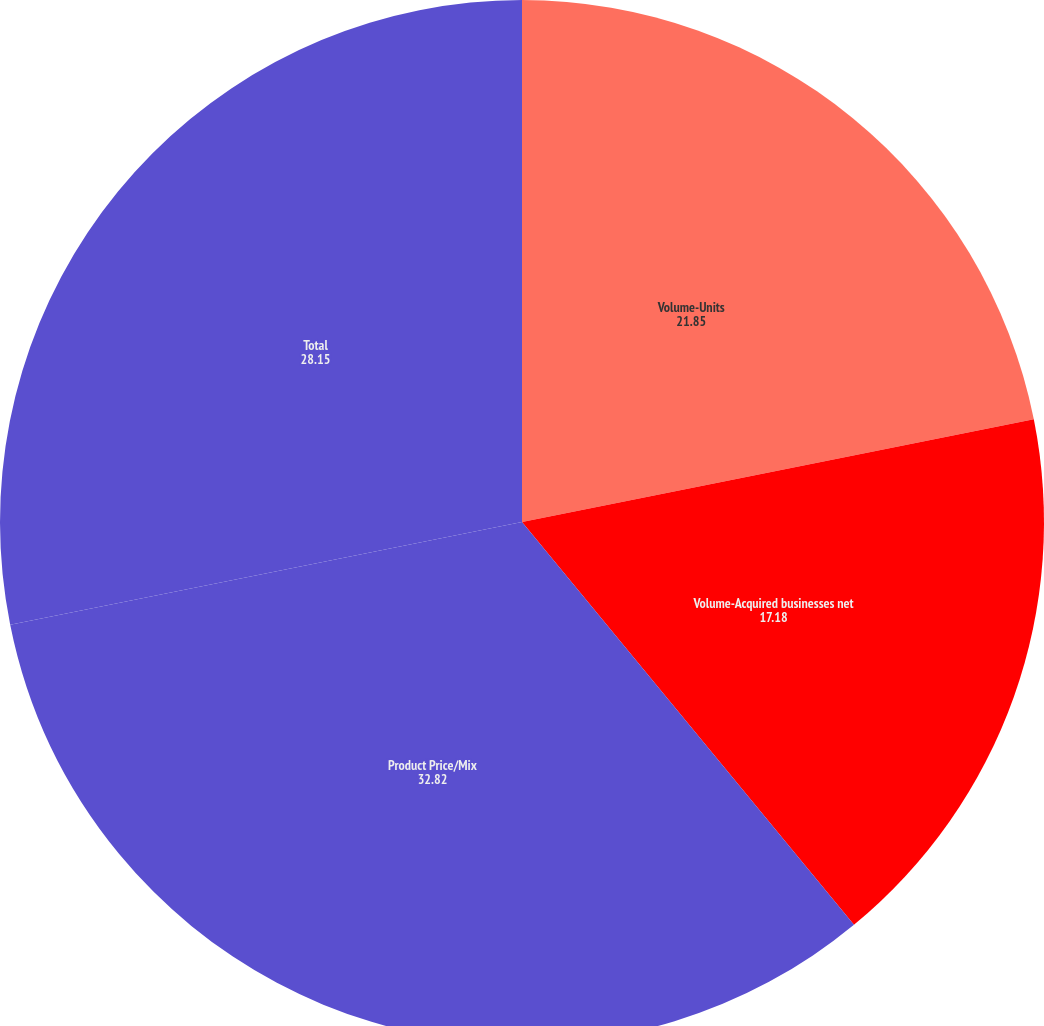Convert chart. <chart><loc_0><loc_0><loc_500><loc_500><pie_chart><fcel>Volume-Units<fcel>Volume-Acquired businesses net<fcel>Product Price/Mix<fcel>Total<nl><fcel>21.85%<fcel>17.18%<fcel>32.82%<fcel>28.15%<nl></chart> 